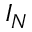Convert formula to latex. <formula><loc_0><loc_0><loc_500><loc_500>I _ { N }</formula> 